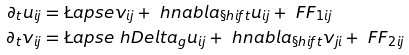<formula> <loc_0><loc_0><loc_500><loc_500>\partial _ { t } u _ { i j } & = \L a p s e v _ { i j } + \ h n a b l a _ { \S h i f t } u _ { i j } + \ F F _ { 1 i j } \\ \partial _ { t } v _ { i j } & = \L a p s e \ h D e l t a _ { g } u _ { i j } + \ h n a b l a _ { \S h i f t } v _ { j i } + \ F F _ { 2 i j }</formula> 